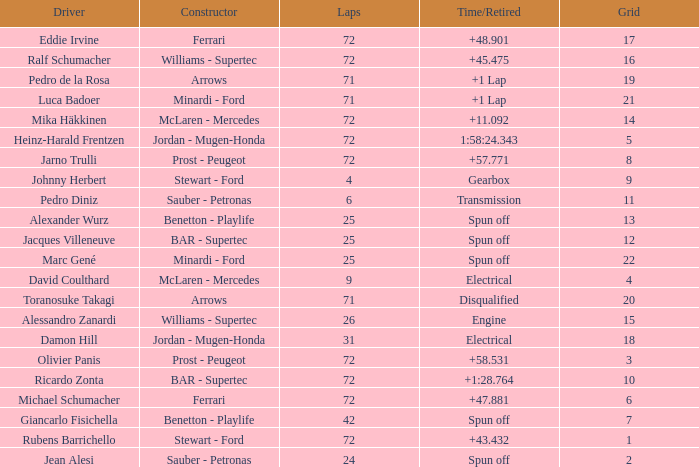What was Alexander Wurz's highest grid with laps of less than 25? None. 